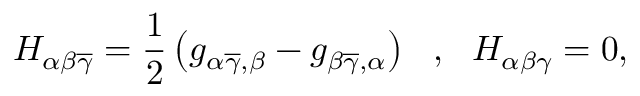<formula> <loc_0><loc_0><loc_500><loc_500>H _ { \alpha \beta \overline { \gamma } } = \frac { 1 } { 2 } \left ( g _ { \alpha \overline { \gamma } , \beta } - g _ { \beta \overline { \gamma } , \alpha } \right ) \ \ , \ \ H _ { \alpha \beta \gamma } = 0 ,</formula> 